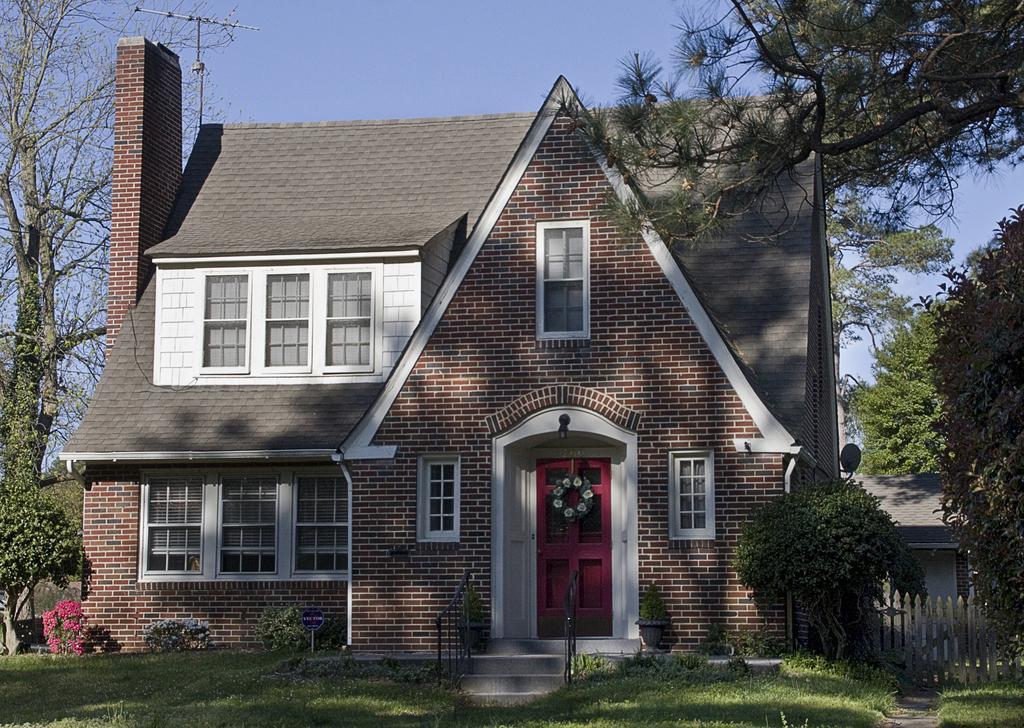Please provide a concise description of this image. In this image there is a house with glass windows and a wooden door, on top of the house there is an antenna, beside the house there are trees, in front of the house there are flowers on plants, in front of the wooden door there are stairs, beside the stairs there is a metal rod fence, beside the house there is wooden fence and there is another house. 